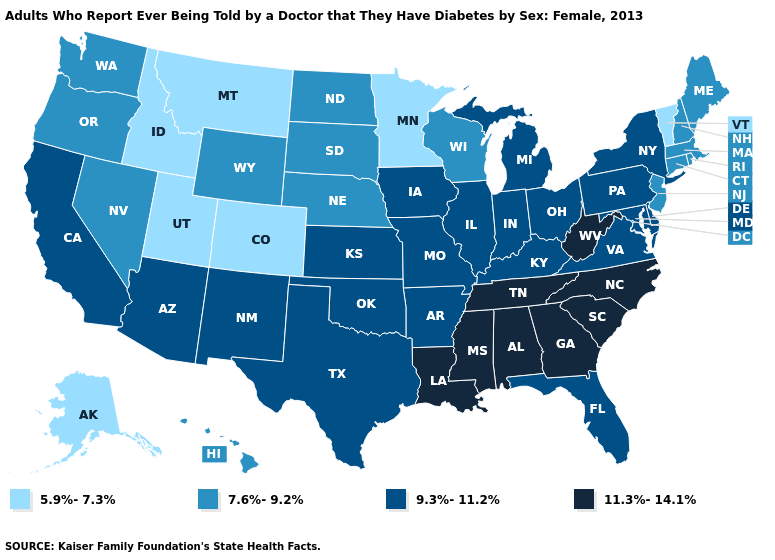Which states hav the highest value in the Northeast?
Concise answer only. New York, Pennsylvania. Does Washington have the same value as Delaware?
Write a very short answer. No. What is the value of Missouri?
Be succinct. 9.3%-11.2%. What is the value of Mississippi?
Write a very short answer. 11.3%-14.1%. What is the highest value in the USA?
Write a very short answer. 11.3%-14.1%. What is the highest value in the Northeast ?
Write a very short answer. 9.3%-11.2%. Does New Mexico have the highest value in the West?
Answer briefly. Yes. Is the legend a continuous bar?
Concise answer only. No. Name the states that have a value in the range 7.6%-9.2%?
Quick response, please. Connecticut, Hawaii, Maine, Massachusetts, Nebraska, Nevada, New Hampshire, New Jersey, North Dakota, Oregon, Rhode Island, South Dakota, Washington, Wisconsin, Wyoming. Name the states that have a value in the range 5.9%-7.3%?
Answer briefly. Alaska, Colorado, Idaho, Minnesota, Montana, Utah, Vermont. What is the value of Georgia?
Short answer required. 11.3%-14.1%. Name the states that have a value in the range 7.6%-9.2%?
Quick response, please. Connecticut, Hawaii, Maine, Massachusetts, Nebraska, Nevada, New Hampshire, New Jersey, North Dakota, Oregon, Rhode Island, South Dakota, Washington, Wisconsin, Wyoming. Which states have the highest value in the USA?
Give a very brief answer. Alabama, Georgia, Louisiana, Mississippi, North Carolina, South Carolina, Tennessee, West Virginia. Does the map have missing data?
Short answer required. No. Which states have the lowest value in the USA?
Concise answer only. Alaska, Colorado, Idaho, Minnesota, Montana, Utah, Vermont. 